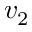<formula> <loc_0><loc_0><loc_500><loc_500>v _ { 2 }</formula> 